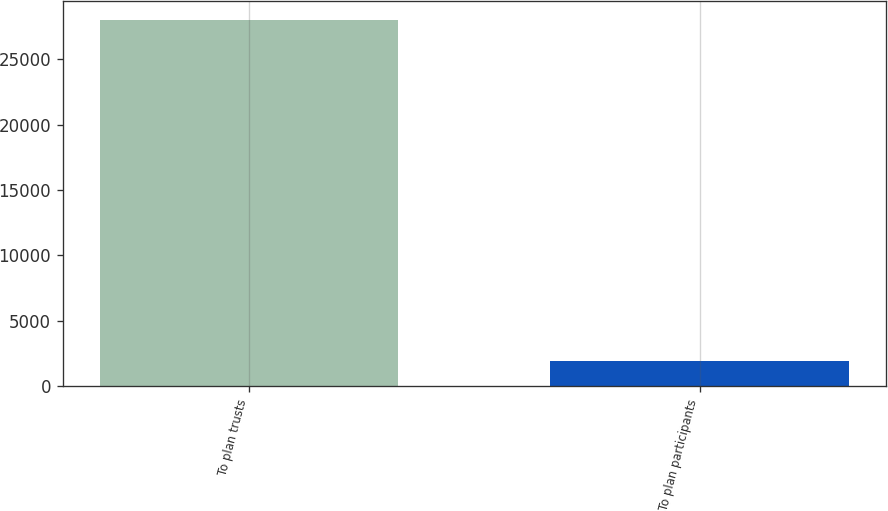<chart> <loc_0><loc_0><loc_500><loc_500><bar_chart><fcel>To plan trusts<fcel>To plan participants<nl><fcel>28000<fcel>1929<nl></chart> 